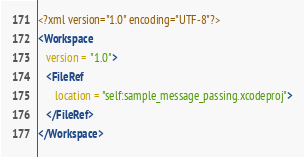Convert code to text. <code><loc_0><loc_0><loc_500><loc_500><_XML_><?xml version="1.0" encoding="UTF-8"?>
<Workspace
   version = "1.0">
   <FileRef
      location = "self:sample_message_passing.xcodeproj">
   </FileRef>
</Workspace>
</code> 